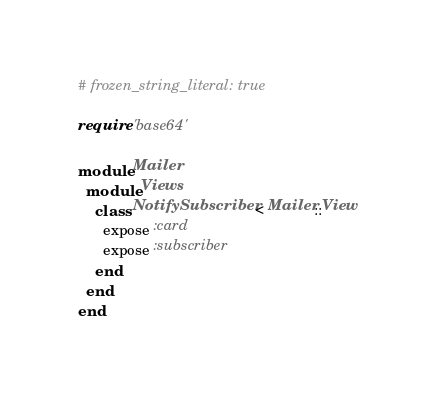<code> <loc_0><loc_0><loc_500><loc_500><_Ruby_># frozen_string_literal: true

require 'base64'

module Mailer
  module Views
    class NotifySubscriber < Mailer::View
      expose :card
      expose :subscriber
    end
  end
end

</code> 